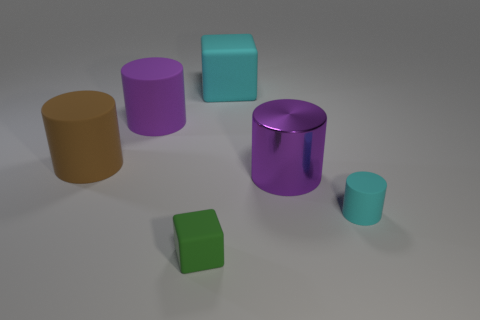Subtract all purple rubber cylinders. How many cylinders are left? 3 Add 1 small green cubes. How many objects exist? 7 Subtract all brown cylinders. How many cylinders are left? 3 Subtract all red blocks. How many purple cylinders are left? 2 Subtract 0 brown blocks. How many objects are left? 6 Subtract all cylinders. How many objects are left? 2 Subtract 4 cylinders. How many cylinders are left? 0 Subtract all brown cylinders. Subtract all cyan spheres. How many cylinders are left? 3 Subtract all rubber balls. Subtract all big cyan rubber cubes. How many objects are left? 5 Add 2 green cubes. How many green cubes are left? 3 